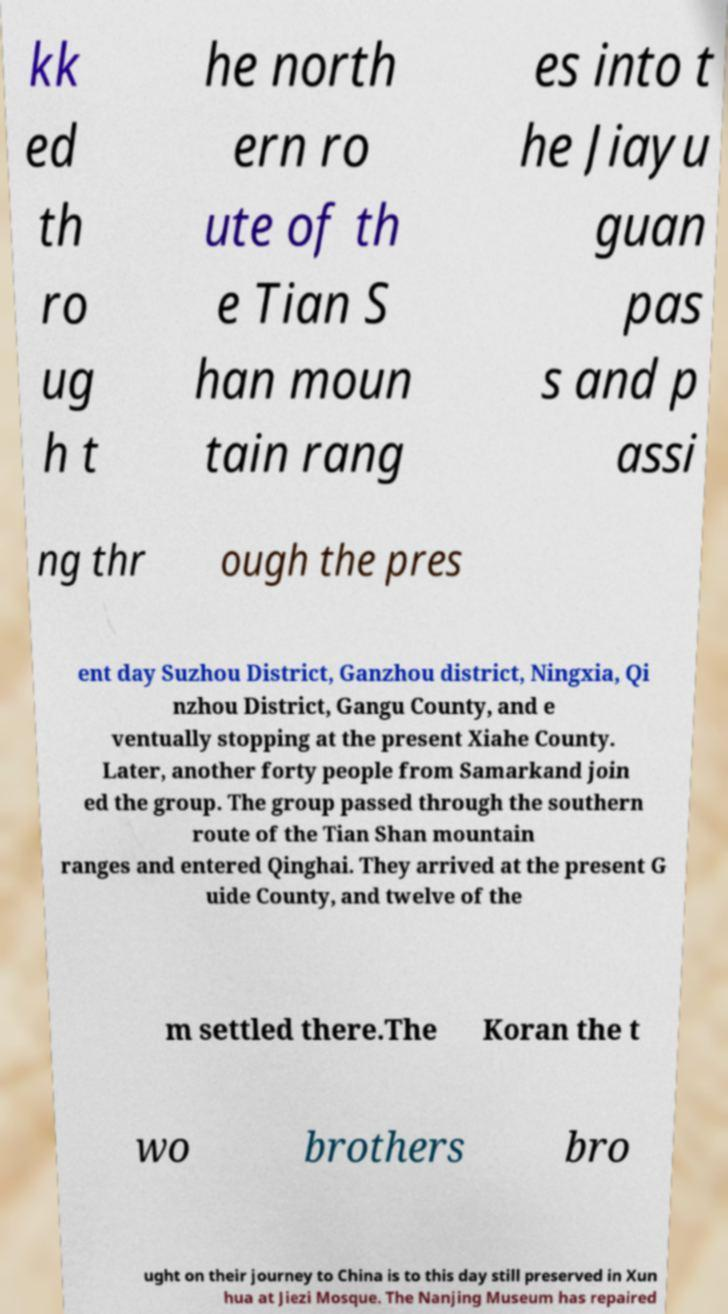There's text embedded in this image that I need extracted. Can you transcribe it verbatim? kk ed th ro ug h t he north ern ro ute of th e Tian S han moun tain rang es into t he Jiayu guan pas s and p assi ng thr ough the pres ent day Suzhou District, Ganzhou district, Ningxia, Qi nzhou District, Gangu County, and e ventually stopping at the present Xiahe County. Later, another forty people from Samarkand join ed the group. The group passed through the southern route of the Tian Shan mountain ranges and entered Qinghai. They arrived at the present G uide County, and twelve of the m settled there.The Koran the t wo brothers bro ught on their journey to China is to this day still preserved in Xun hua at Jiezi Mosque. The Nanjing Museum has repaired 